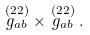<formula> <loc_0><loc_0><loc_500><loc_500>\stackrel { ( 2 2 ) } { g _ { a b } } \times \stackrel { ( 2 2 ) } { g _ { a b } } .</formula> 